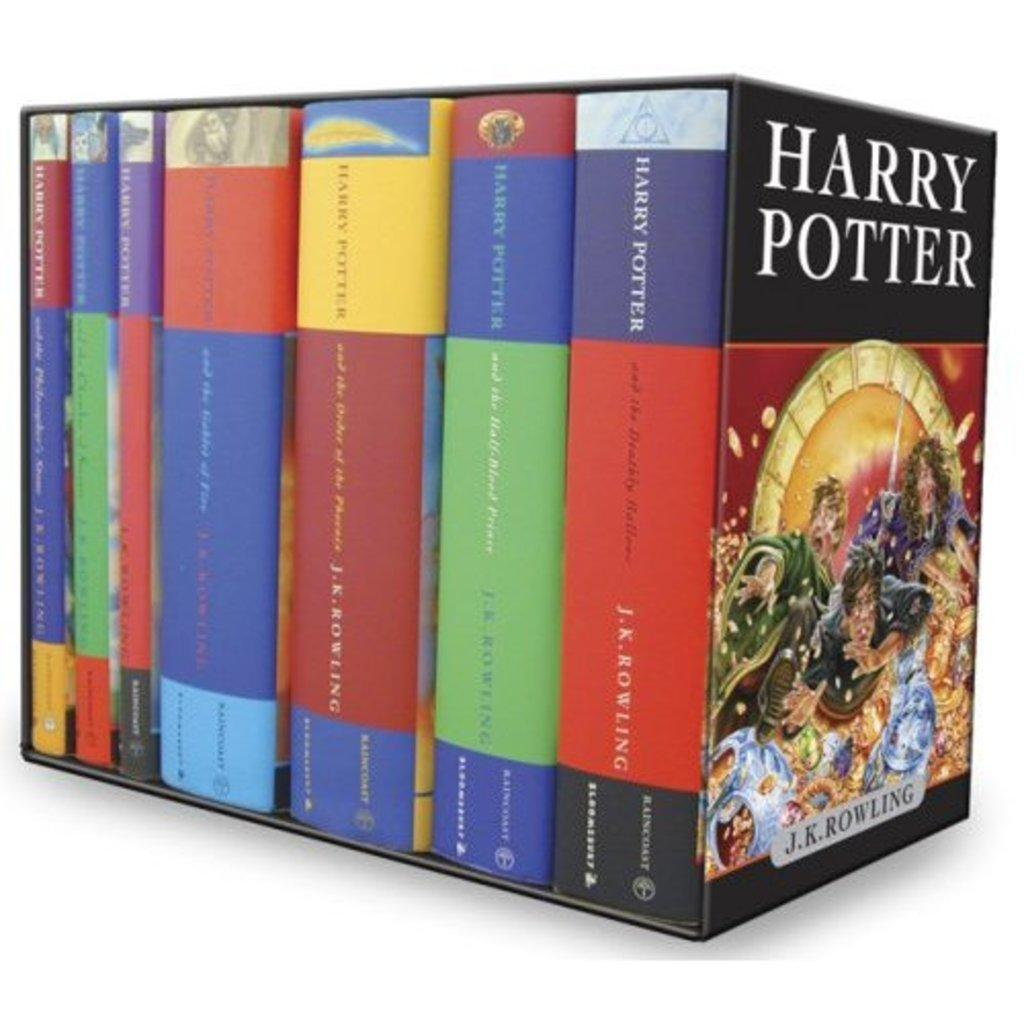<image>
Describe the image concisely. boxed set of all seven harry potter books by j.k. rowling 